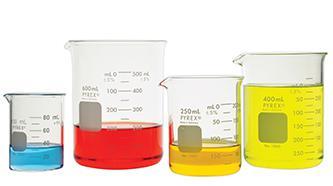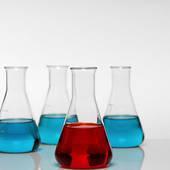The first image is the image on the left, the second image is the image on the right. Examine the images to the left and right. Is the description "The right image contains exactly four flasks." accurate? Answer yes or no. Yes. The first image is the image on the left, the second image is the image on the right. Considering the images on both sides, is "All glass vessels contain a non-clear liquid, and one set of beakers shares the same shape." valid? Answer yes or no. Yes. 